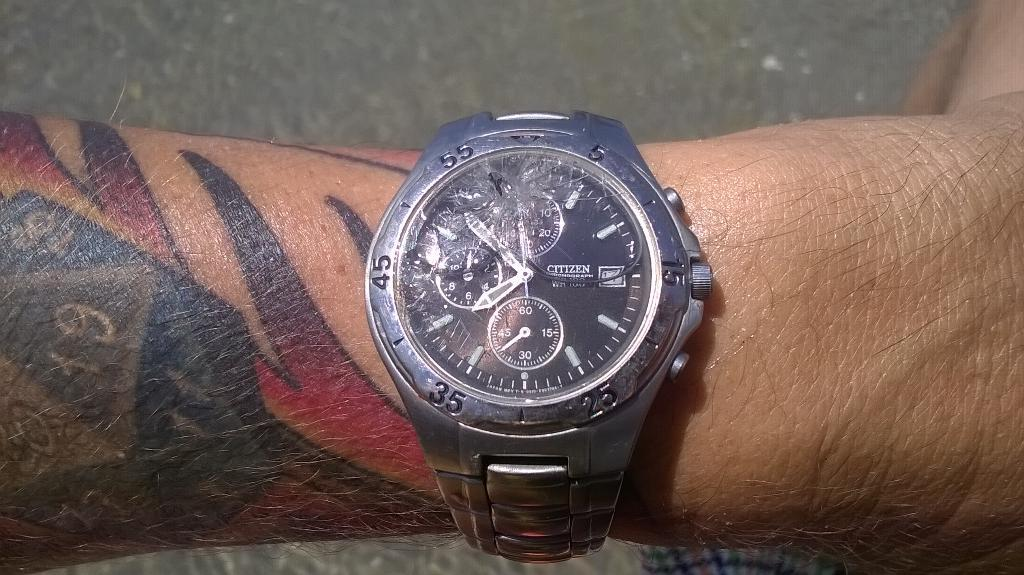<image>
Give a short and clear explanation of the subsequent image. a watch on a tattoed mans wtrist the time is 8:45 